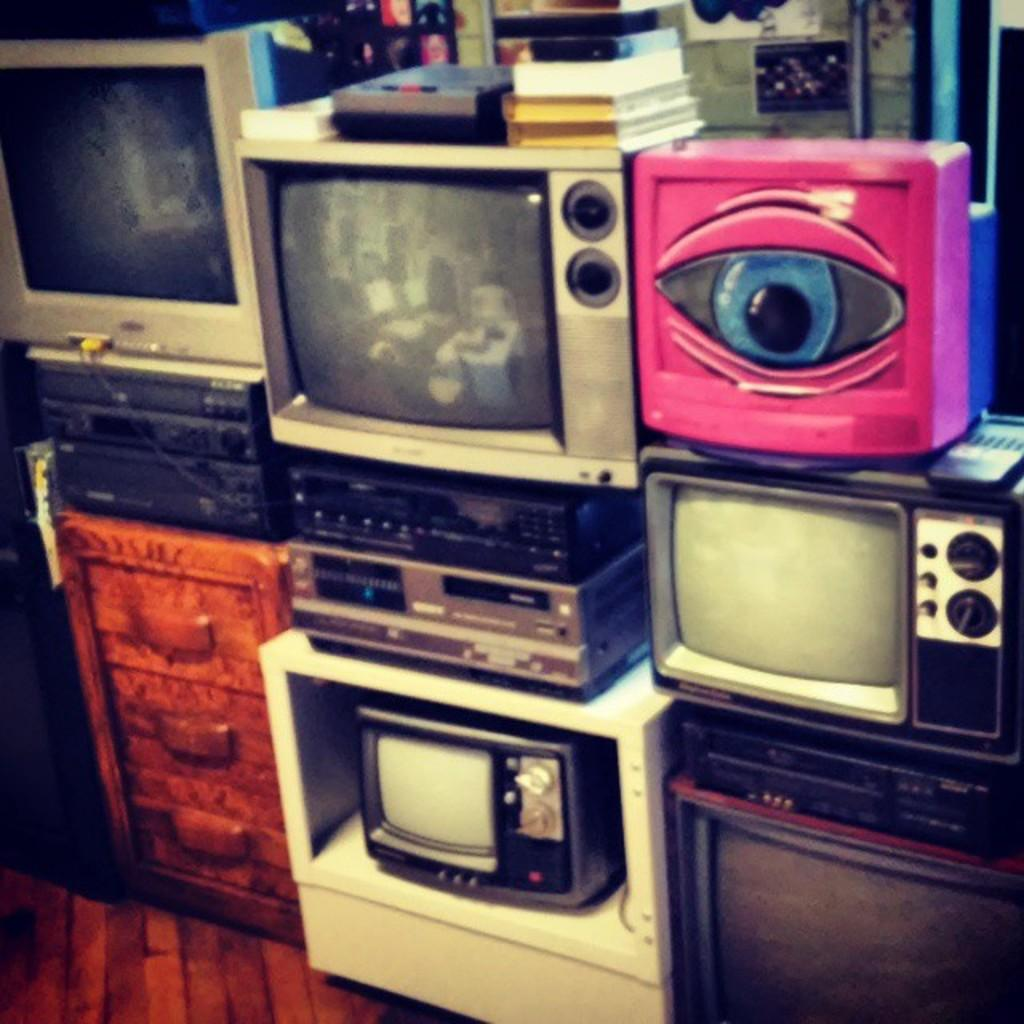What electronic devices are present in the image? There are TVs in the picture. What is placed on top of the TVs? There are books at the top of the TVs. What type of furniture is located at the bottom of the picture? There is a table at the bottom of the picture. How many mailboxes can be seen in the image? There are no mailboxes present in the image. What type of tent is visible in the image? There is no tent present in the image. 